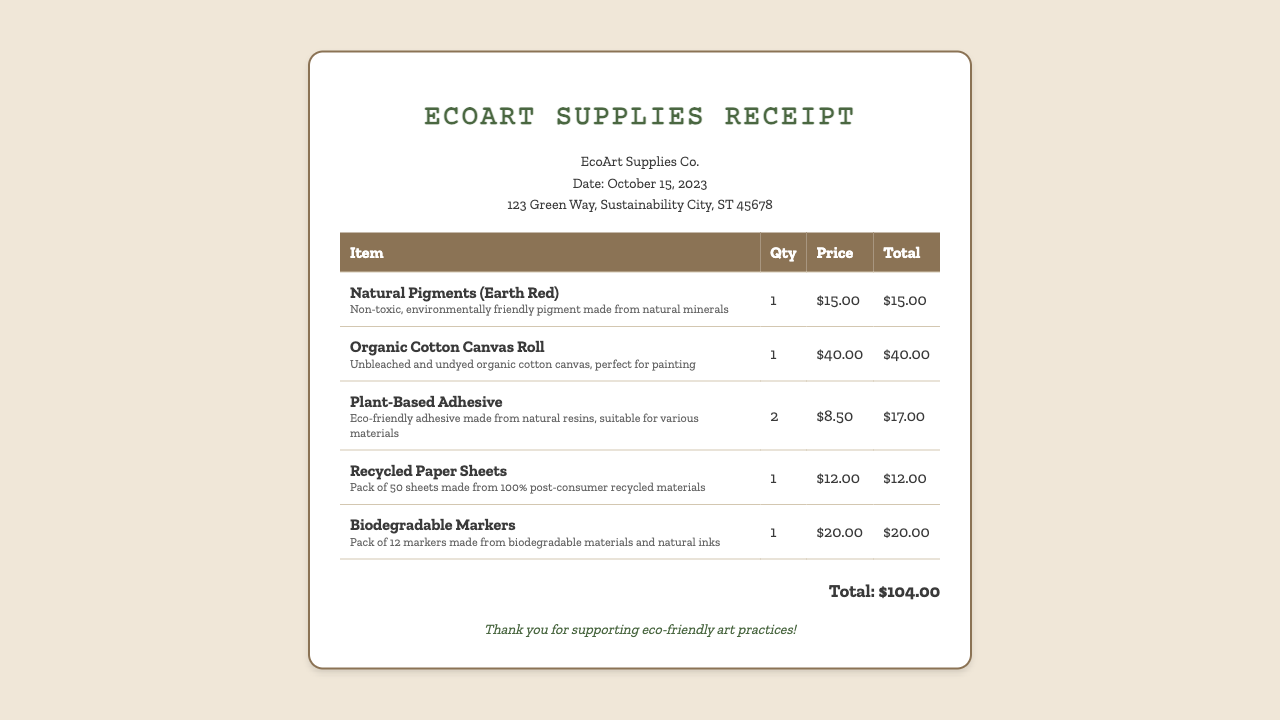What is the vendor name? The vendor name is mentioned at the top of the receipt and is "EcoArt Supplies Co."
Answer: EcoArt Supplies Co What is the date of purchase? The date of purchase is clearly stated in the document, which is "October 15, 2023."
Answer: October 15, 2023 How many items were purchased? The number of items can be counted in the line items of the table; there are five individual items listed.
Answer: 5 What is the price of the Organic Cotton Canvas Roll? The price for the Organic Cotton Canvas Roll is specified in the item price column as "$40.00."
Answer: $40.00 What is the total cost of the purchase? The total cost of all purchased items is provided at the bottom of the receipt as "Total: $104.00."
Answer: $104.00 What type of adhesive is listed? The adhesive mentioned is specified as "Plant-Based Adhesive."
Answer: Plant-Based Adhesive How many Plant-Based Adhesives were purchased? The quantity for the Plant-Based Adhesive is indicated in the quantity column as "2."
Answer: 2 What material are the biodegradable markers made from? The biodegradable markers are made from "biodegradable materials and natural inks" as described in their details.
Answer: Biodegradable materials and natural inks What is unique about the Recycled Paper Sheets? The Recycled Paper Sheets are highlighted as made from "100% post-consumer recycled materials."
Answer: 100% post-consumer recycled materials 